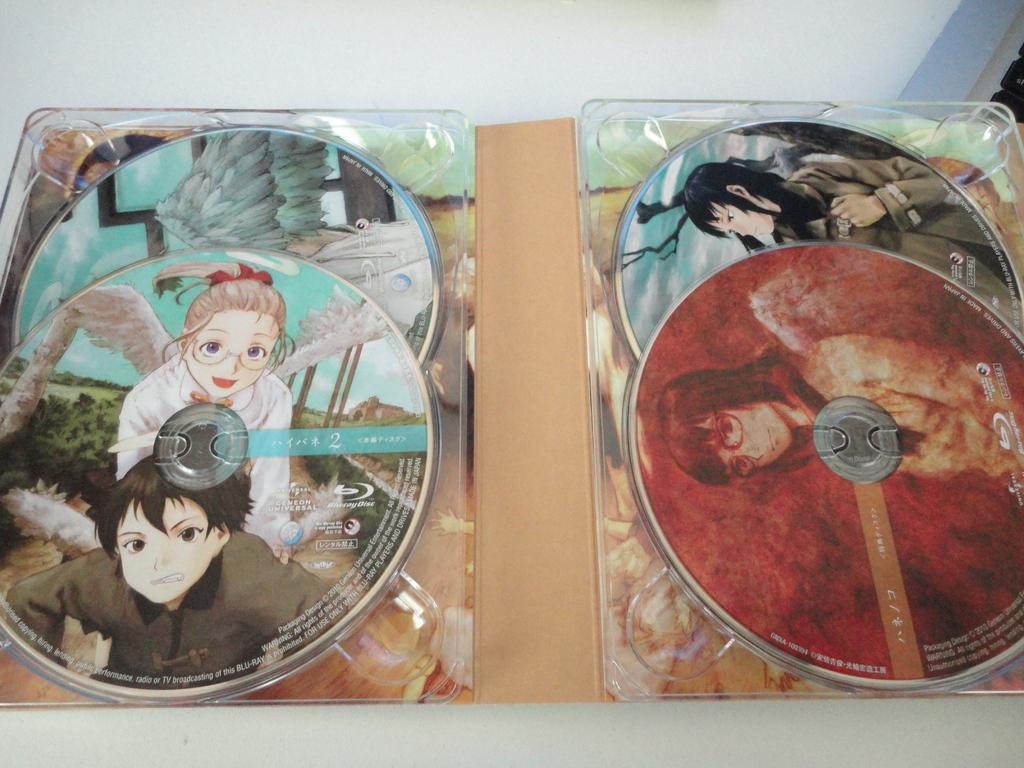What objects are present in the image? There are disks in the image. What can be seen on the disks? The disks have depictions of people on them. How does the smoke affect the disks in the image? There is no smoke present in the image, so it cannot affect the disks. 